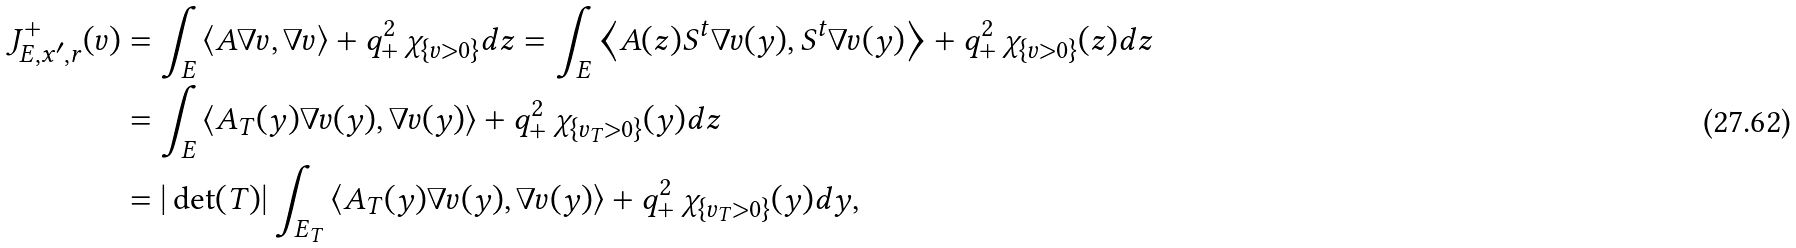<formula> <loc_0><loc_0><loc_500><loc_500>J ^ { + } _ { E , x ^ { \prime } , r } ( v ) & = \int _ { E } \left \langle A \nabla v , \nabla v \right \rangle + q ^ { 2 } _ { + } \, \chi _ { \{ v > 0 \} } d z = \int _ { E } \left \langle A ( z ) S ^ { t } \nabla v ( y ) , S ^ { t } \nabla v ( y ) \right \rangle + q ^ { 2 } _ { + } \, \chi _ { \{ v > 0 \} } ( z ) d z \\ & = \int _ { E } \left \langle A _ { T } ( y ) \nabla v ( y ) , \nabla v ( y ) \right \rangle + q ^ { 2 } _ { + } \, \chi _ { \{ v _ { T } > 0 \} } ( y ) d z \\ & = | \det ( T ) | \int _ { E _ { T } } \left \langle A _ { T } ( y ) \nabla v ( y ) , \nabla v ( y ) \right \rangle + q ^ { 2 } _ { + } \, \chi _ { \{ v _ { T } > 0 \} } ( y ) d y ,</formula> 